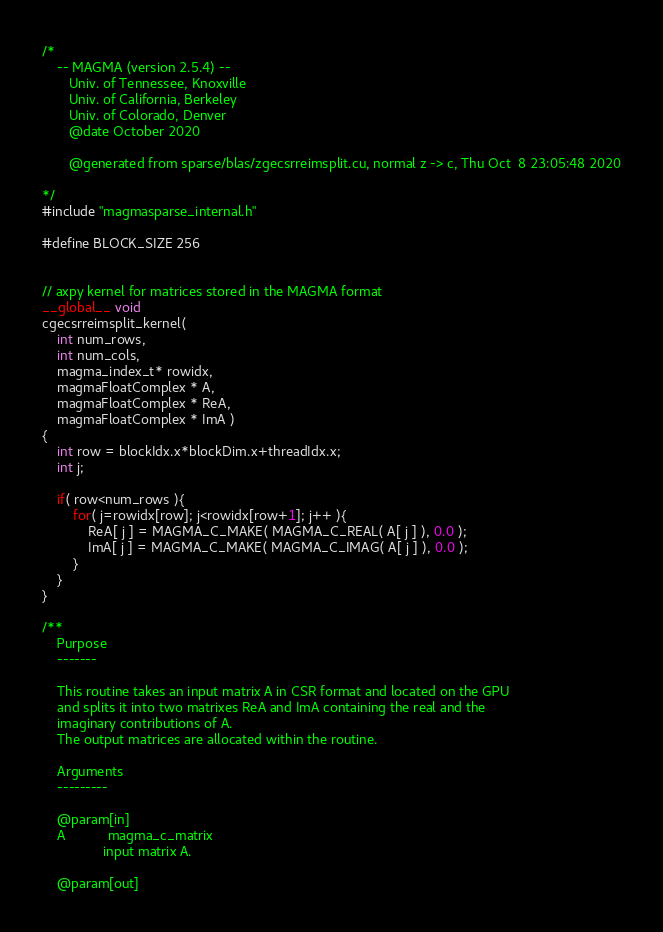Convert code to text. <code><loc_0><loc_0><loc_500><loc_500><_Cuda_>/*
    -- MAGMA (version 2.5.4) --
       Univ. of Tennessee, Knoxville
       Univ. of California, Berkeley
       Univ. of Colorado, Denver
       @date October 2020

       @generated from sparse/blas/zgecsrreimsplit.cu, normal z -> c, Thu Oct  8 23:05:48 2020

*/
#include "magmasparse_internal.h"

#define BLOCK_SIZE 256


// axpy kernel for matrices stored in the MAGMA format
__global__ void 
cgecsrreimsplit_kernel( 
    int num_rows, 
    int num_cols,  
    magma_index_t* rowidx,
    magmaFloatComplex * A, 
    magmaFloatComplex * ReA, 
    magmaFloatComplex * ImA )
{
    int row = blockIdx.x*blockDim.x+threadIdx.x;
    int j;

    if( row<num_rows ){
        for( j=rowidx[row]; j<rowidx[row+1]; j++ ){
            ReA[ j ] = MAGMA_C_MAKE( MAGMA_C_REAL( A[ j ] ), 0.0 );
            ImA[ j ] = MAGMA_C_MAKE( MAGMA_C_IMAG( A[ j ] ), 0.0 );
        }
    }
}

/**
    Purpose
    -------
    
    This routine takes an input matrix A in CSR format and located on the GPU
    and splits it into two matrixes ReA and ImA containing the real and the 
    imaginary contributions of A.
    The output matrices are allocated within the routine.
    
    Arguments
    ---------

    @param[in]
    A           magma_c_matrix
                input matrix A.
                
    @param[out]</code> 